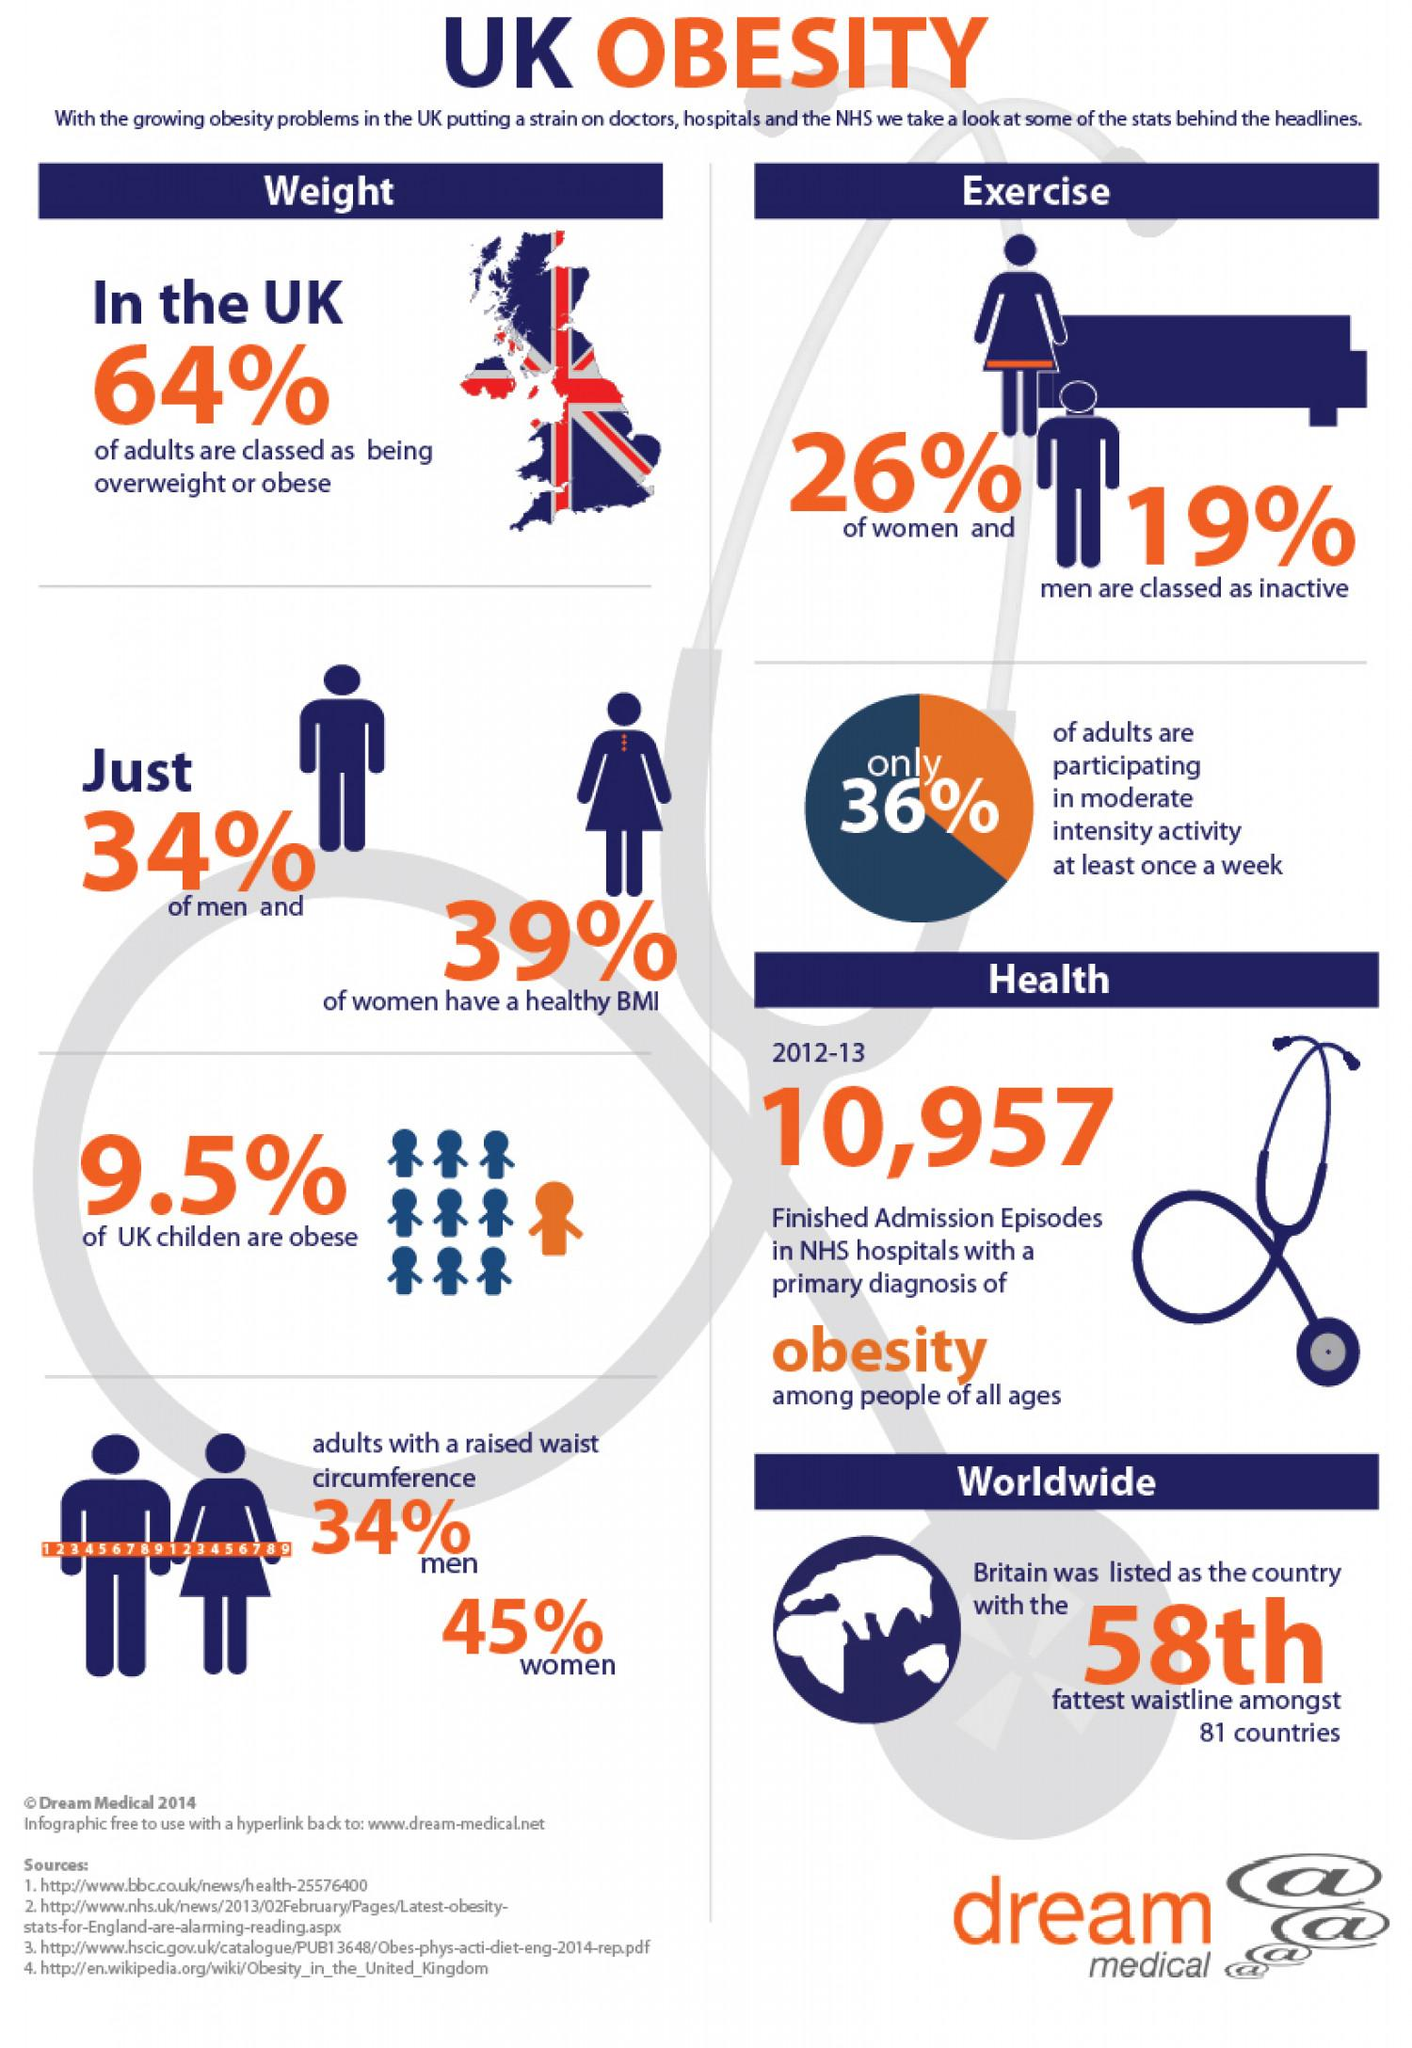List a handful of essential elements in this visual. The women contribute 11% more to the total number of adults with raised waist circumference than men, according to the data. According to the data, there are significantly more inactive men than inactive women, with a difference of 7%. 